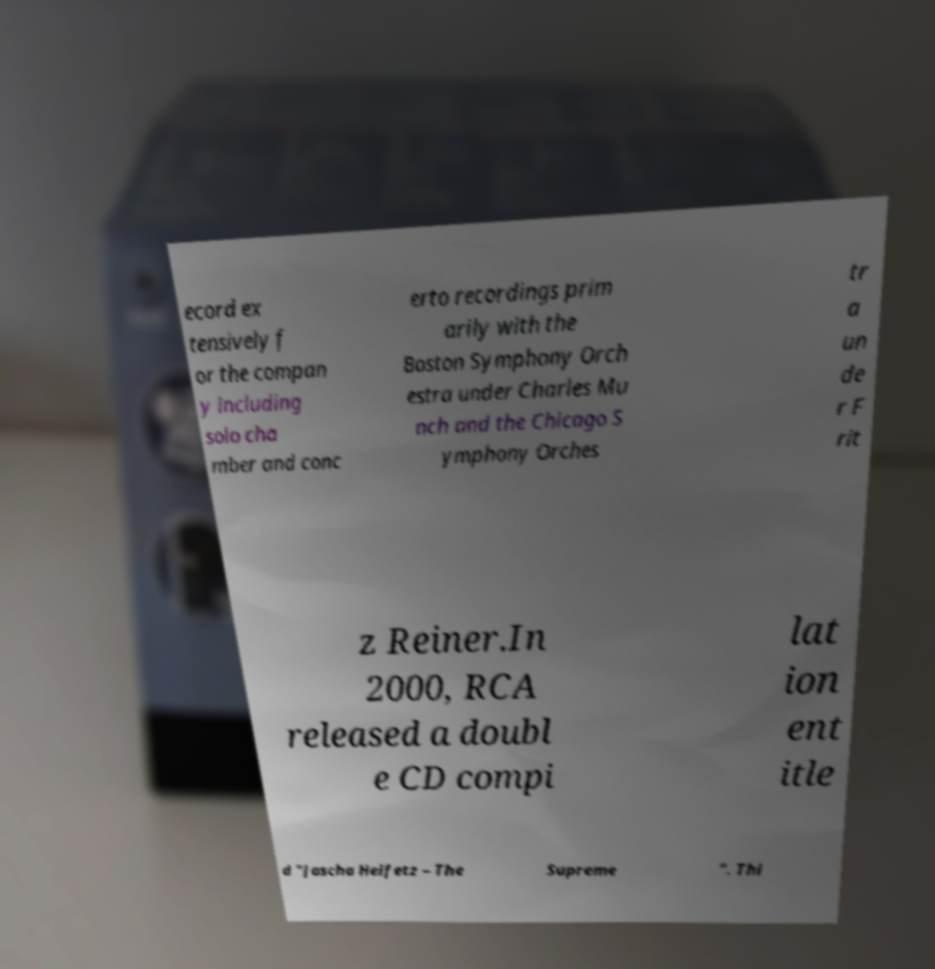For documentation purposes, I need the text within this image transcribed. Could you provide that? ecord ex tensively f or the compan y including solo cha mber and conc erto recordings prim arily with the Boston Symphony Orch estra under Charles Mu nch and the Chicago S ymphony Orches tr a un de r F rit z Reiner.In 2000, RCA released a doubl e CD compi lat ion ent itle d "Jascha Heifetz – The Supreme ". Thi 